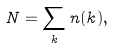<formula> <loc_0><loc_0><loc_500><loc_500>N = \sum _ { k } n ( k ) ,</formula> 